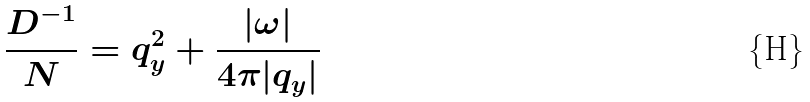Convert formula to latex. <formula><loc_0><loc_0><loc_500><loc_500>\frac { D ^ { - 1 } } { N } = q _ { y } ^ { 2 } + \frac { | \omega | } { 4 \pi | q _ { y } | }</formula> 